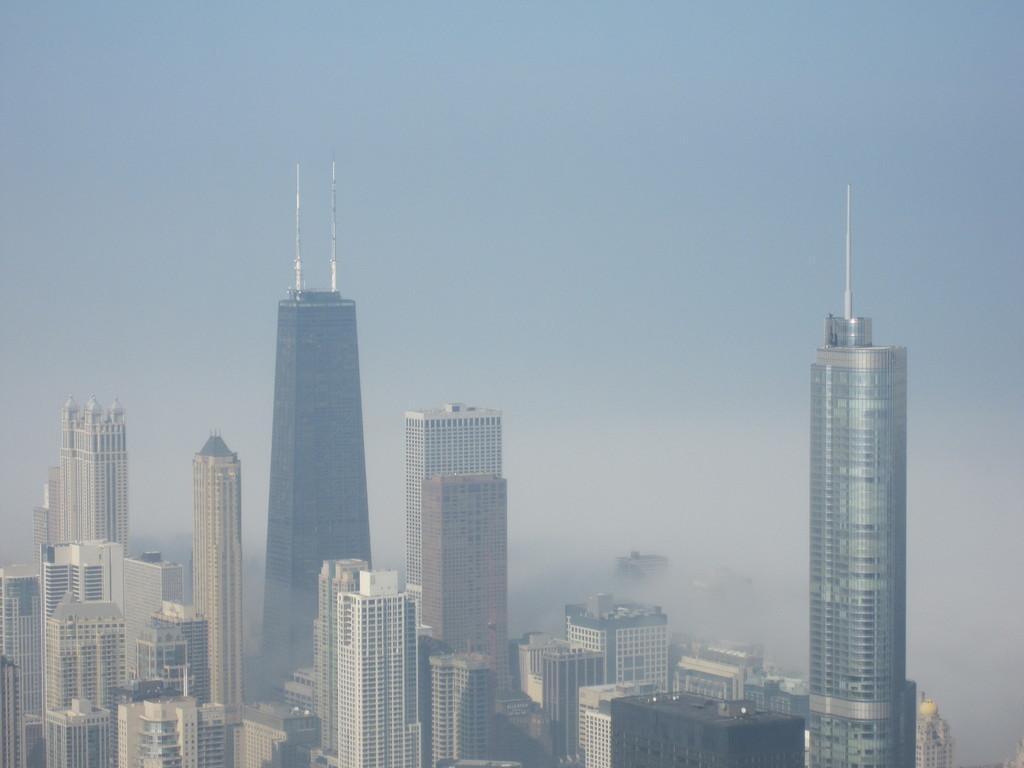In one or two sentences, can you explain what this image depicts? In this image there are buildings, in the background there is the sky. 